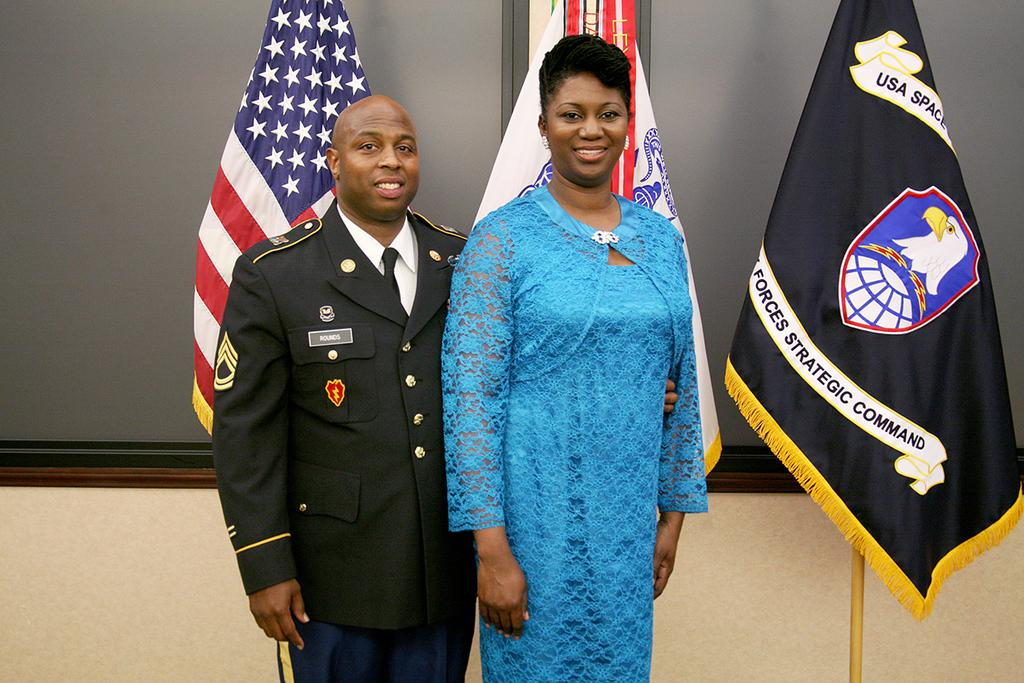Provide a one-sentence caption for the provided image. A man in military uniform named Rounds stands with a lady in a blue dress in from of the American Flag and a US Space Forces flag. 